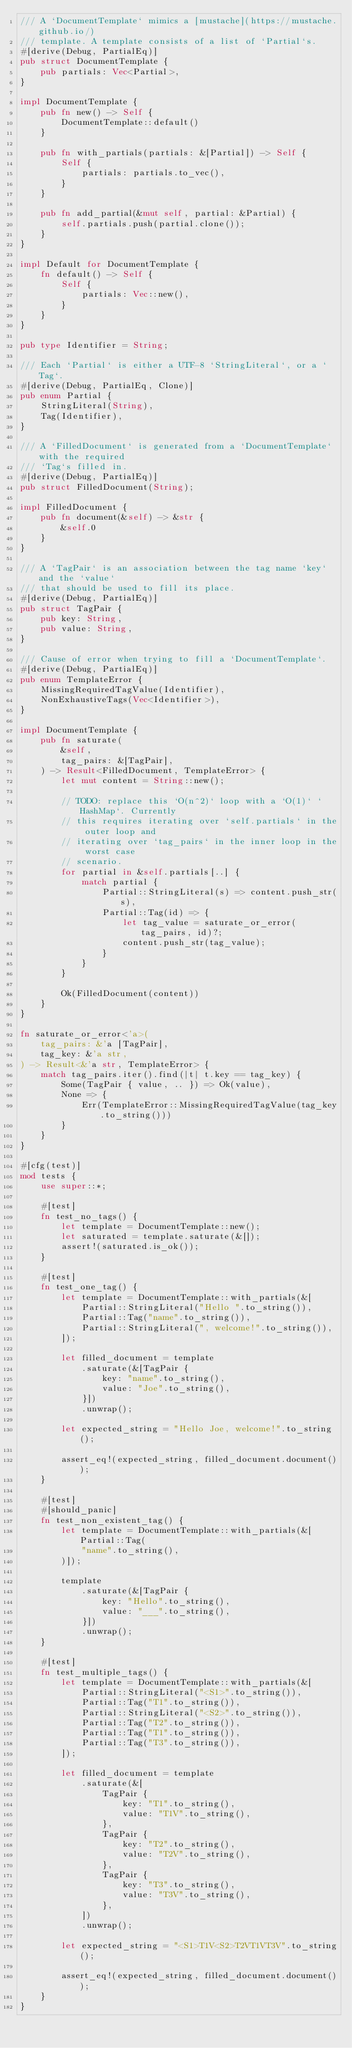Convert code to text. <code><loc_0><loc_0><loc_500><loc_500><_Rust_>/// A `DocumentTemplate` mimics a [mustache](https://mustache.github.io/)
/// template. A template consists of a list of `Partial`s.
#[derive(Debug, PartialEq)]
pub struct DocumentTemplate {
    pub partials: Vec<Partial>,
}

impl DocumentTemplate {
    pub fn new() -> Self {
        DocumentTemplate::default()
    }

    pub fn with_partials(partials: &[Partial]) -> Self {
        Self {
            partials: partials.to_vec(),
        }
    }

    pub fn add_partial(&mut self, partial: &Partial) {
        self.partials.push(partial.clone());
    }
}

impl Default for DocumentTemplate {
    fn default() -> Self {
        Self {
            partials: Vec::new(),
        }
    }
}

pub type Identifier = String;

/// Each `Partial` is either a UTF-8 `StringLiteral`, or a `Tag`.
#[derive(Debug, PartialEq, Clone)]
pub enum Partial {
    StringLiteral(String),
    Tag(Identifier),
}

/// A `FilledDocument` is generated from a `DocumentTemplate` with the required
/// `Tag`s filled in.
#[derive(Debug, PartialEq)]
pub struct FilledDocument(String);

impl FilledDocument {
    pub fn document(&self) -> &str {
        &self.0
    }
}

/// A `TagPair` is an association between the tag name `key` and the `value`
/// that should be used to fill its place.
#[derive(Debug, PartialEq)]
pub struct TagPair {
    pub key: String,
    pub value: String,
}

/// Cause of error when trying to fill a `DocumentTemplate`.
#[derive(Debug, PartialEq)]
pub enum TemplateError {
    MissingRequiredTagValue(Identifier),
    NonExhaustiveTags(Vec<Identifier>),
}

impl DocumentTemplate {
    pub fn saturate(
        &self,
        tag_pairs: &[TagPair],
    ) -> Result<FilledDocument, TemplateError> {
        let mut content = String::new();

        // TODO: replace this `O(n^2)` loop with a `O(1)` `HashMap`. Currently
        // this requires iterating over `self.partials` in the outer loop and
        // iterating over `tag_pairs` in the inner loop in the worst case
        // scenario.
        for partial in &self.partials[..] {
            match partial {
                Partial::StringLiteral(s) => content.push_str(s),
                Partial::Tag(id) => {
                    let tag_value = saturate_or_error(tag_pairs, id)?;
                    content.push_str(tag_value);
                }
            }
        }

        Ok(FilledDocument(content))
    }
}

fn saturate_or_error<'a>(
    tag_pairs: &'a [TagPair],
    tag_key: &'a str,
) -> Result<&'a str, TemplateError> {
    match tag_pairs.iter().find(|t| t.key == tag_key) {
        Some(TagPair { value, .. }) => Ok(value),
        None => {
            Err(TemplateError::MissingRequiredTagValue(tag_key.to_string()))
        }
    }
}

#[cfg(test)]
mod tests {
    use super::*;

    #[test]
    fn test_no_tags() {
        let template = DocumentTemplate::new();
        let saturated = template.saturate(&[]);
        assert!(saturated.is_ok());
    }

    #[test]
    fn test_one_tag() {
        let template = DocumentTemplate::with_partials(&[
            Partial::StringLiteral("Hello ".to_string()),
            Partial::Tag("name".to_string()),
            Partial::StringLiteral(", welcome!".to_string()),
        ]);

        let filled_document = template
            .saturate(&[TagPair {
                key: "name".to_string(),
                value: "Joe".to_string(),
            }])
            .unwrap();

        let expected_string = "Hello Joe, welcome!".to_string();

        assert_eq!(expected_string, filled_document.document());
    }

    #[test]
    #[should_panic]
    fn test_non_existent_tag() {
        let template = DocumentTemplate::with_partials(&[Partial::Tag(
            "name".to_string(),
        )]);

        template
            .saturate(&[TagPair {
                key: "Hello".to_string(),
                value: "___".to_string(),
            }])
            .unwrap();
    }

    #[test]
    fn test_multiple_tags() {
        let template = DocumentTemplate::with_partials(&[
            Partial::StringLiteral("<S1>".to_string()),
            Partial::Tag("T1".to_string()),
            Partial::StringLiteral("<S2>".to_string()),
            Partial::Tag("T2".to_string()),
            Partial::Tag("T1".to_string()),
            Partial::Tag("T3".to_string()),
        ]);

        let filled_document = template
            .saturate(&[
                TagPair {
                    key: "T1".to_string(),
                    value: "T1V".to_string(),
                },
                TagPair {
                    key: "T2".to_string(),
                    value: "T2V".to_string(),
                },
                TagPair {
                    key: "T3".to_string(),
                    value: "T3V".to_string(),
                },
            ])
            .unwrap();

        let expected_string = "<S1>T1V<S2>T2VT1VT3V".to_string();

        assert_eq!(expected_string, filled_document.document());
    }
}
</code> 